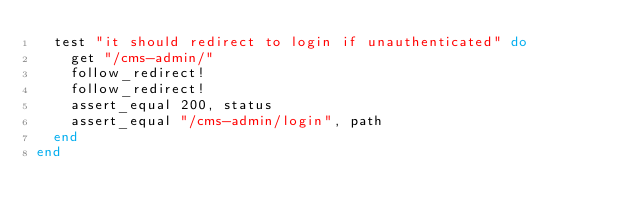Convert code to text. <code><loc_0><loc_0><loc_500><loc_500><_Ruby_>  test "it should redirect to login if unauthenticated" do
    get "/cms-admin/"
    follow_redirect!
    follow_redirect!
    assert_equal 200, status
    assert_equal "/cms-admin/login", path
  end
end
</code> 